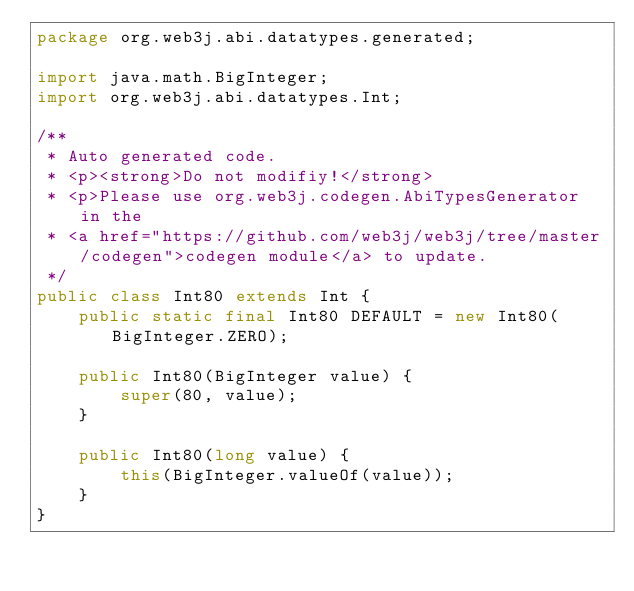Convert code to text. <code><loc_0><loc_0><loc_500><loc_500><_Java_>package org.web3j.abi.datatypes.generated;

import java.math.BigInteger;
import org.web3j.abi.datatypes.Int;

/**
 * Auto generated code.
 * <p><strong>Do not modifiy!</strong>
 * <p>Please use org.web3j.codegen.AbiTypesGenerator in the 
 * <a href="https://github.com/web3j/web3j/tree/master/codegen">codegen module</a> to update.
 */
public class Int80 extends Int {
    public static final Int80 DEFAULT = new Int80(BigInteger.ZERO);

    public Int80(BigInteger value) {
        super(80, value);
    }

    public Int80(long value) {
        this(BigInteger.valueOf(value));
    }
}
</code> 